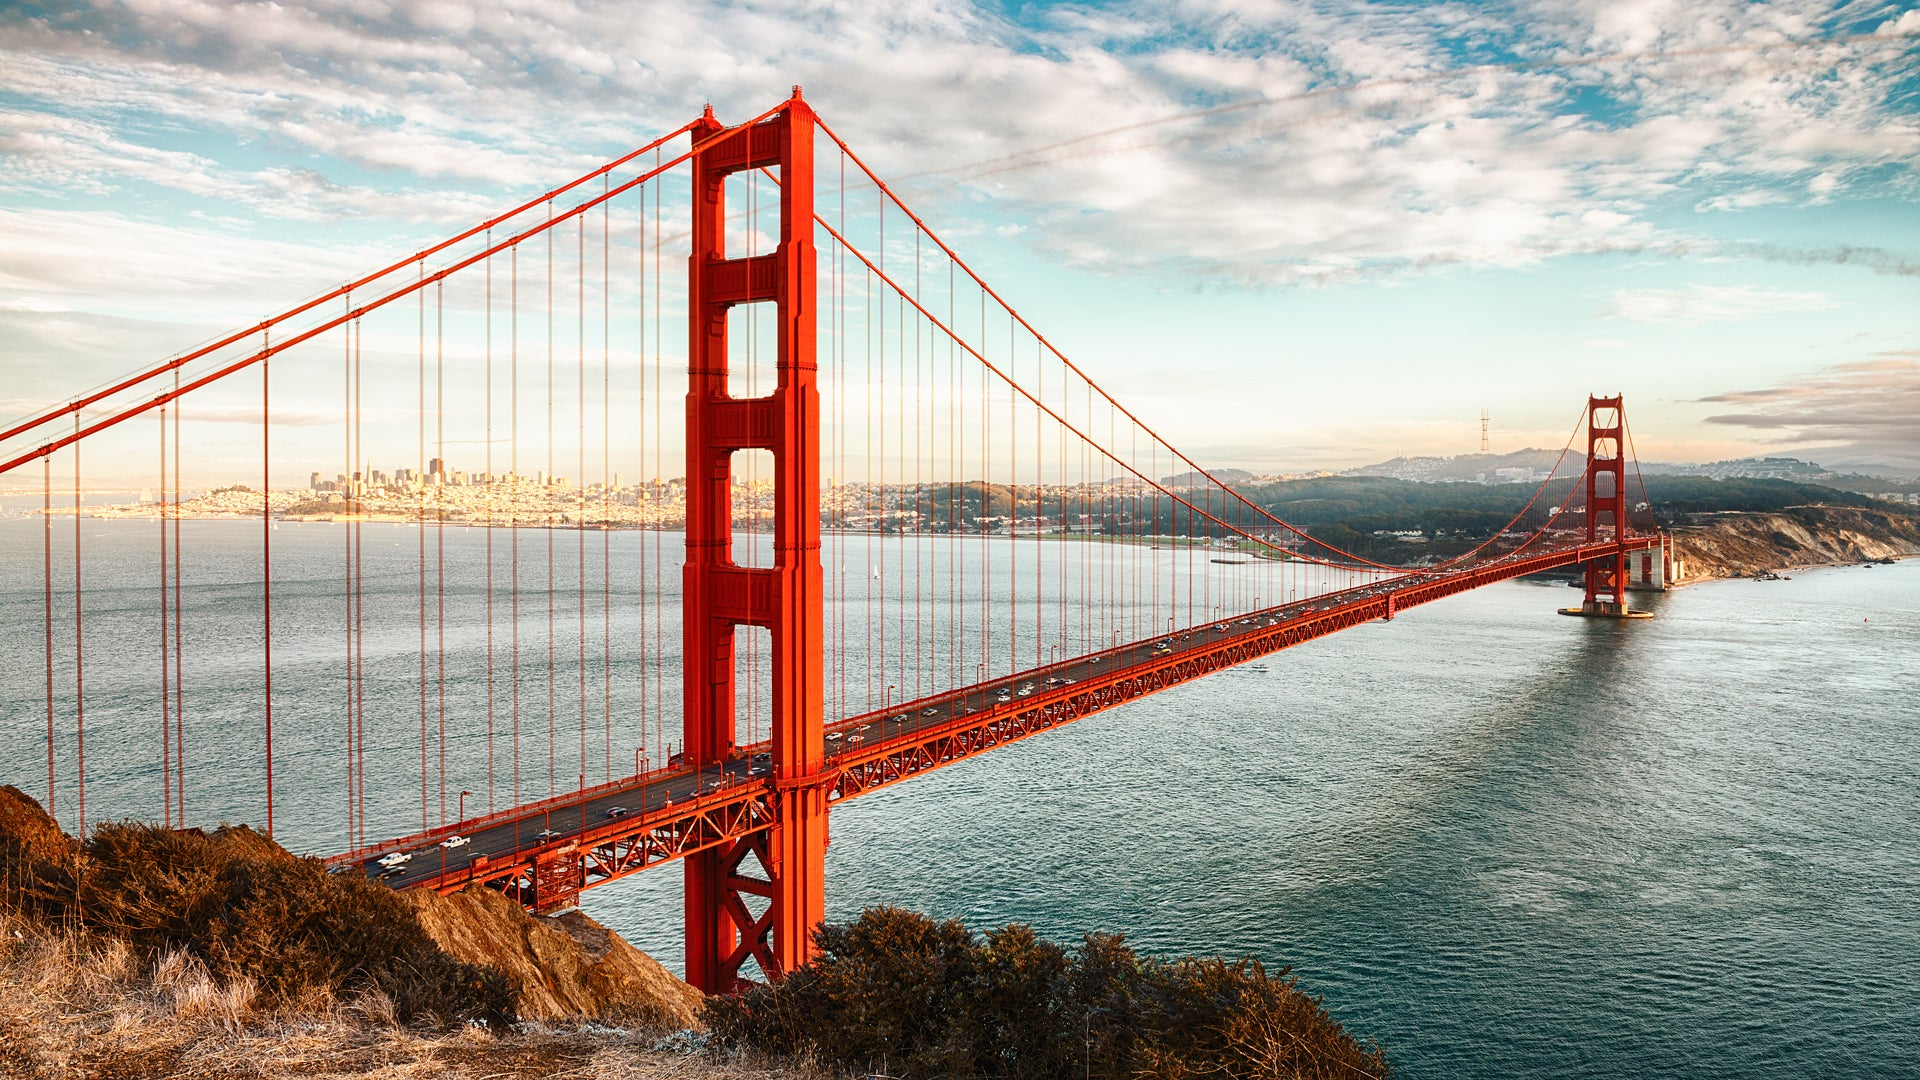Can you describe the atmosphere and mood of the scene? The atmosphere in the image is serene and awe-inspiring. The clear blue sky with a few scattered clouds conveys a sense of calm and tranquility, while the magnificent red structure of the Golden Gate Bridge evokes a feeling of grandeur and human achievement. The distant city skyline adds a touch of urban life without overwhelming the natural beauty of the scene. Overall, the mood is balanced and peaceful, inviting viewers to appreciate both the man-made marvel and the surrounding natural elements. 